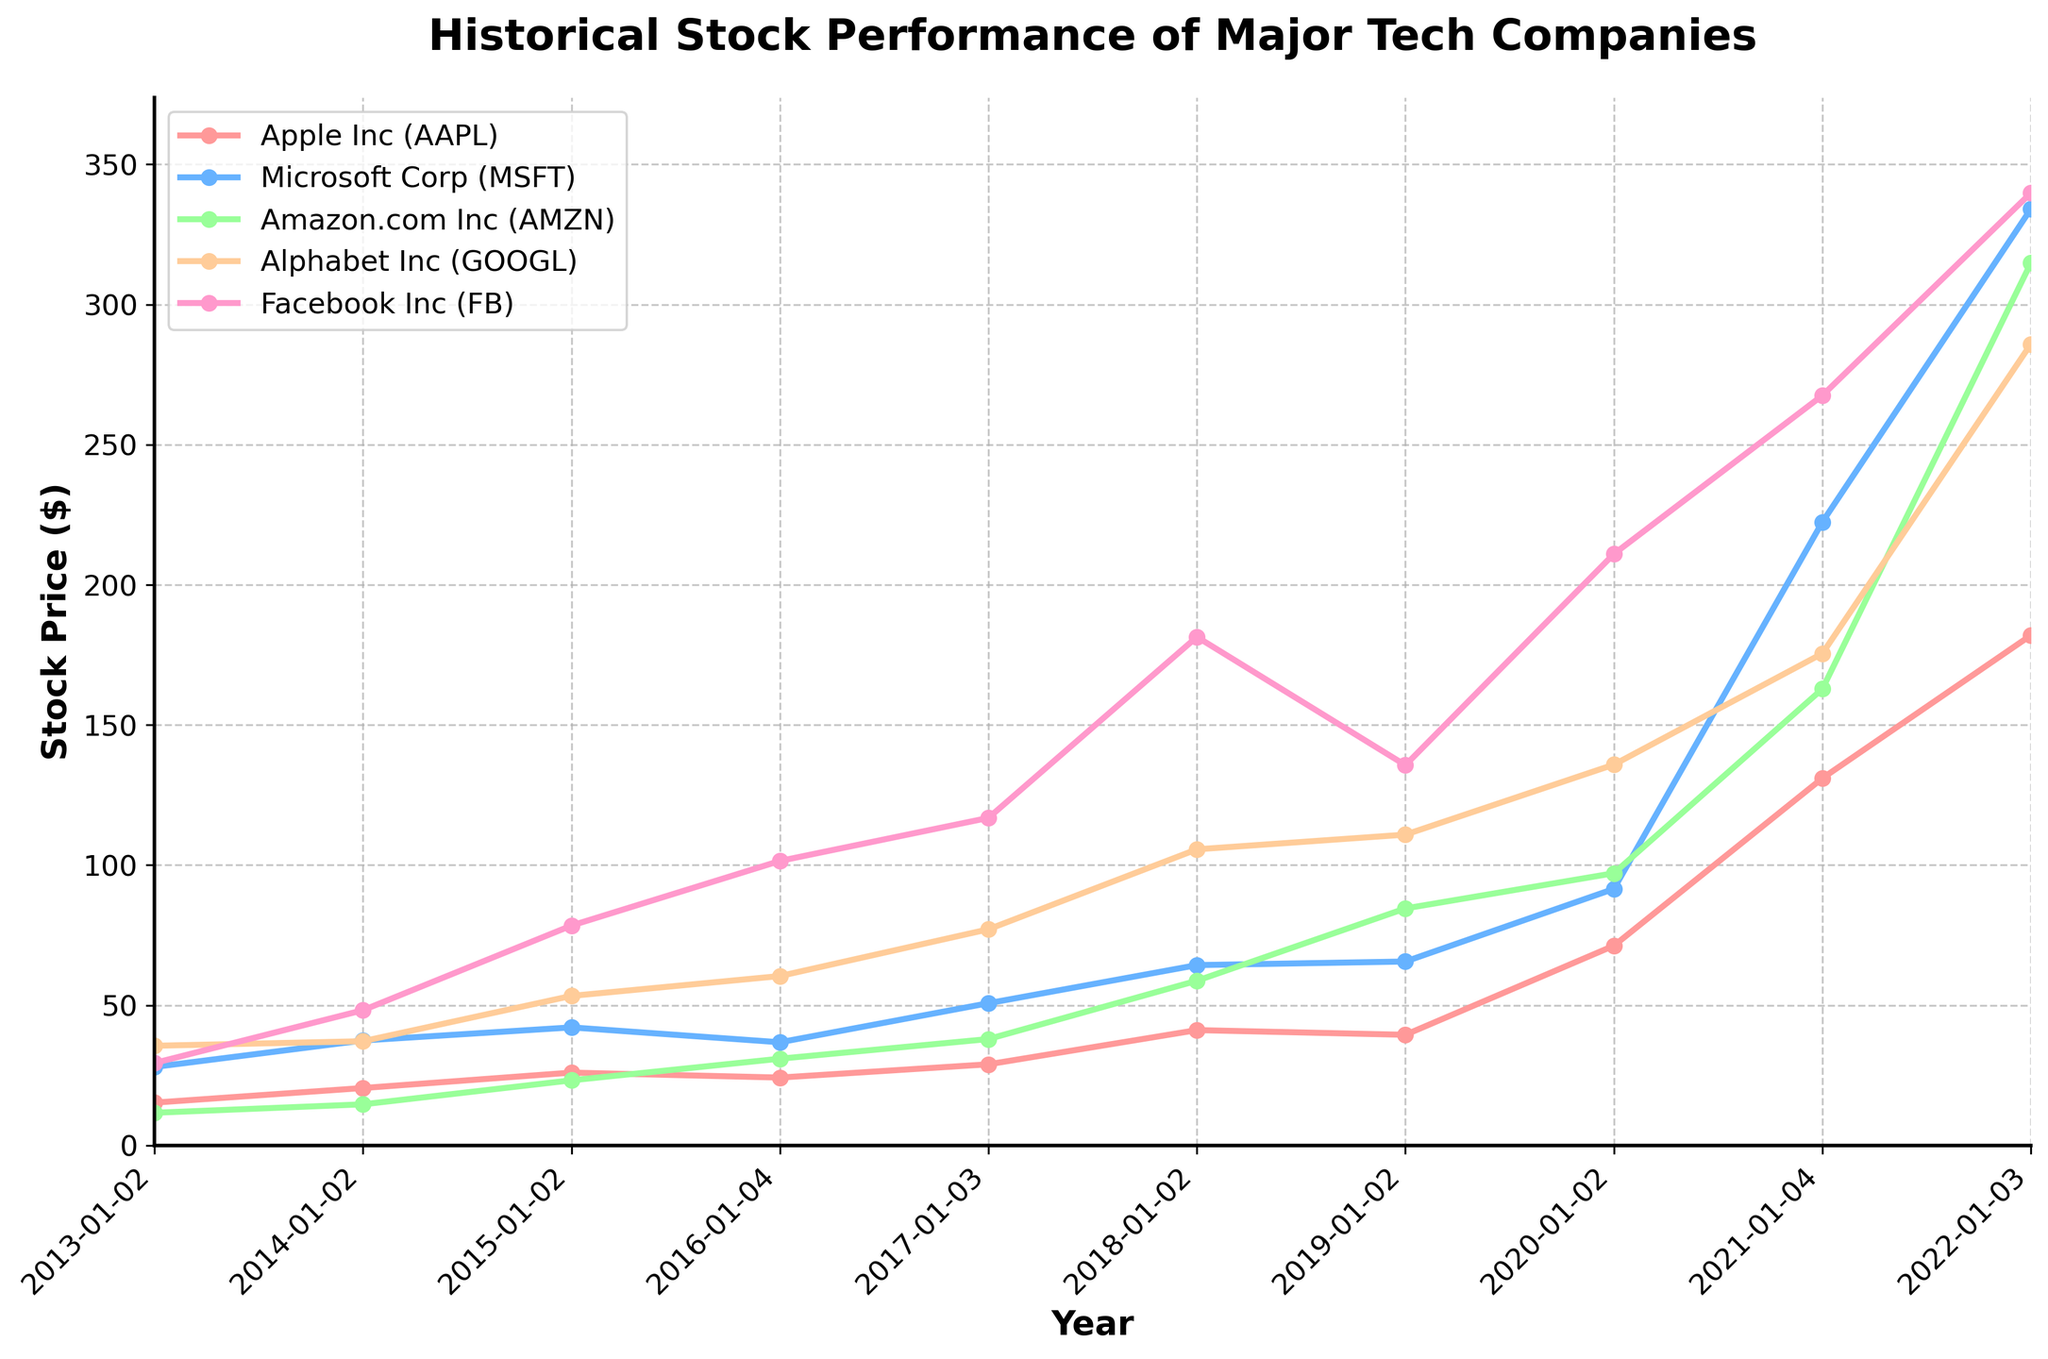What is the title of the plot? The title of the plot is positioned at the top center in bold font and larger size compared to other texts. By reading directly from the plot, the title can be identified.
Answer: Historical Stock Performance of Major Tech Companies Which company had the highest stock price in 2022? By examining the data points plotted for the year 2022 on the x-axis and finding the highest y-value, which represents the stock prices, one can determine the company with the highest stock price.
Answer: Facebook Inc (FB) How many data points are plotted for each company? To determine the number of data points, count the x-axis ticks for each company's plot. Given the span from 2013 to 2022 inclusive, each company will have the same number of annual data points.
Answer: 10 Which two companies had a closing stock price above $200 in 2021? Checking the stock prices for the year 2021, find the companies with stock prices above $200 by comparing the y-values to 200 and noting the corresponding companies.
Answer: Microsoft Corp (MSFT) and Facebook Inc (FB) By how much did Amazon's stock price increase from 2013 to 2022? To find the increase, identify Amazon's stock prices in 2013 and 2022 and calculate the difference by subtracting the 2013 price from the 2022 price.
Answer: $303.15 (314.81 - 11.66) Which company showed the most consistent upward trend over the decade? Examine the slopes of the lines representing each company's stock prices. The company with the most uniformly increasing line indicates a consistent upward trend.
Answer: Microsoft Corp (MSFT) What was the average stock price of Alphabet Inc (GOOGL) over the decade? Sum the stock prices for Alphabet Inc listed for each year and divide by the number of years (which is 10) to get the average stock price.
Answer: $107.84 ((35.56 + 37.19 + 53.36 + 60.44 + 77.12 + 105.65 + 110.89 + 135.87 + 175.51 + 285.91)/10) Did any company experience a decline in stock price between any two consecutive years? If so, which one(s)? Analyze each company's annual data points to identify years where the stock price decreased from the previous year. Make note of the company and the years of decline.
Answer: Apple Inc (AAPL) (2015-2016), Microsoft Corp (MSFT) (2015-2016), Amazon.com Inc (AMZN) (2018-2019) Who had the highest stock price growth rate between 2013 and 2022? Calculate the growth rate for each company as (stock price in 2022 - stock price in 2013) / stock price in 2013. Compare these growth rates to determine the highest one.
Answer: Facebook Inc (FB) 